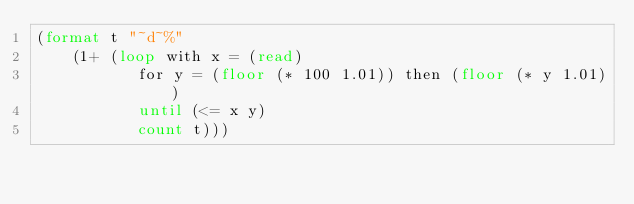<code> <loc_0><loc_0><loc_500><loc_500><_Lisp_>(format t "~d~%"
	(1+ (loop with x = (read)
	       for y = (floor (* 100 1.01)) then (floor (* y 1.01))
	       until (<= x y)
	       count t)))</code> 